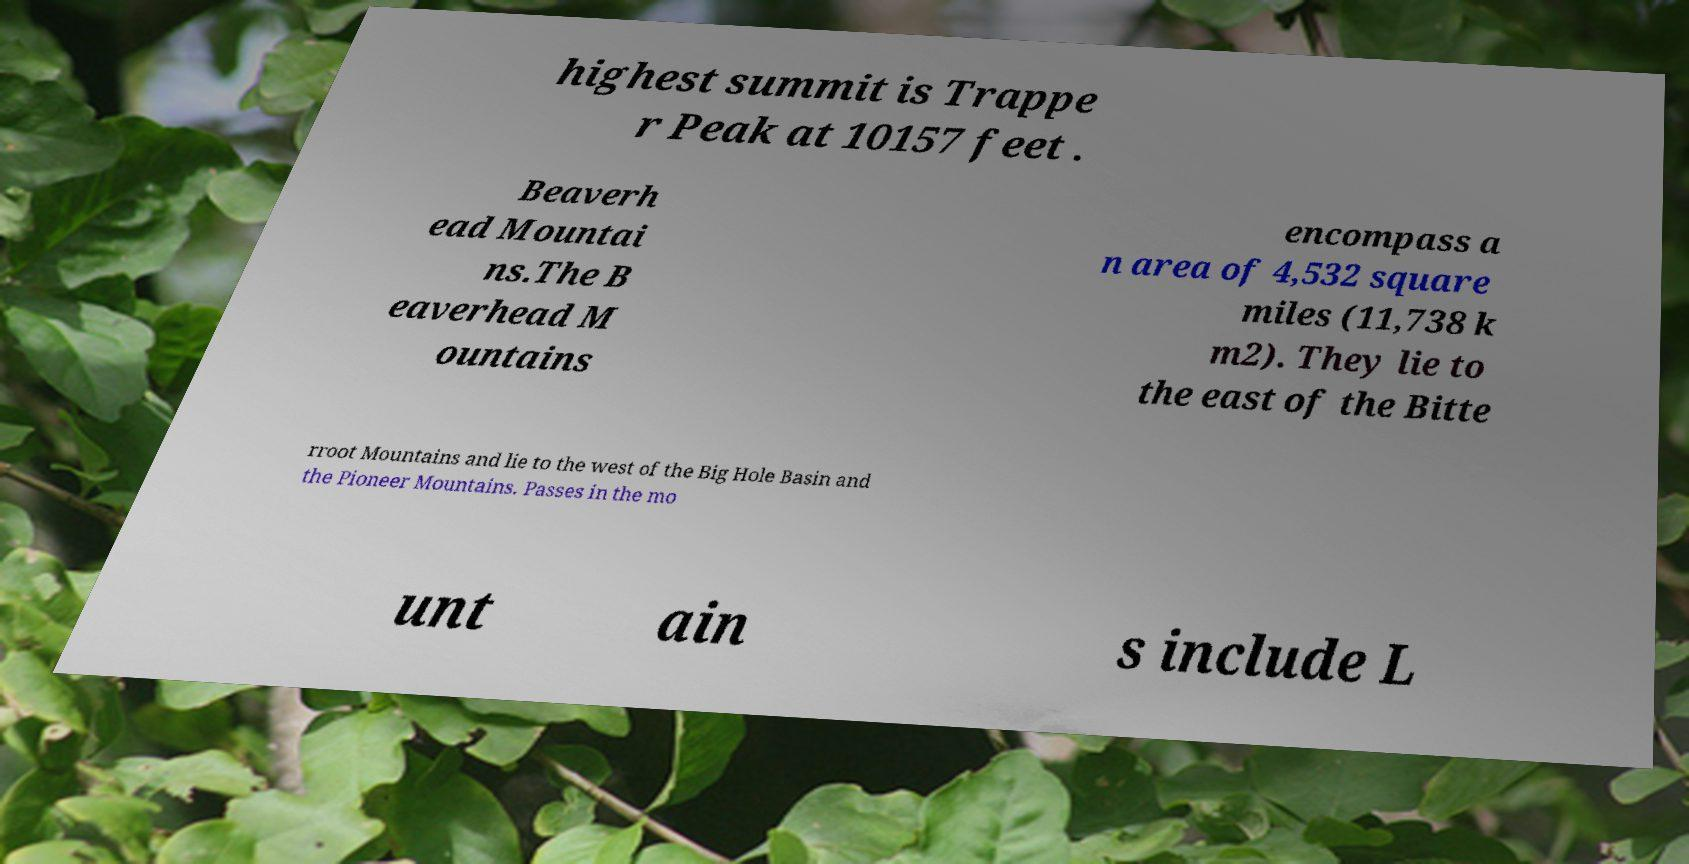What messages or text are displayed in this image? I need them in a readable, typed format. highest summit is Trappe r Peak at 10157 feet . Beaverh ead Mountai ns.The B eaverhead M ountains encompass a n area of 4,532 square miles (11,738 k m2). They lie to the east of the Bitte rroot Mountains and lie to the west of the Big Hole Basin and the Pioneer Mountains. Passes in the mo unt ain s include L 